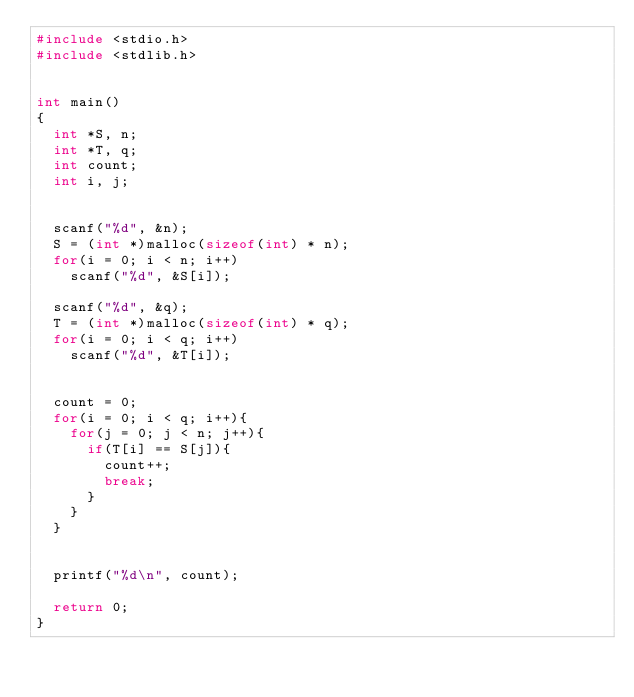Convert code to text. <code><loc_0><loc_0><loc_500><loc_500><_C_>#include <stdio.h>
#include <stdlib.h>


int main()
{
	int *S, n;
	int *T, q;
	int count;
	int i, j;


	scanf("%d", &n);
	S = (int *)malloc(sizeof(int) * n);
	for(i = 0; i < n; i++)
		scanf("%d", &S[i]);

	scanf("%d", &q);
	T = (int *)malloc(sizeof(int) * q);
	for(i = 0; i < q; i++)
		scanf("%d", &T[i]);


	count = 0;
	for(i = 0; i < q; i++){
		for(j = 0; j < n; j++){
			if(T[i] == S[j]){
				count++;
				break;
			}
		}
	}


	printf("%d\n", count);

	return 0;
}
</code> 